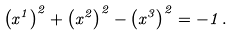Convert formula to latex. <formula><loc_0><loc_0><loc_500><loc_500>\left ( x ^ { 1 } \right ) ^ { 2 } + \left ( x ^ { 2 } \right ) ^ { 2 } - \left ( x ^ { 3 } \right ) ^ { 2 } = - 1 \, .</formula> 